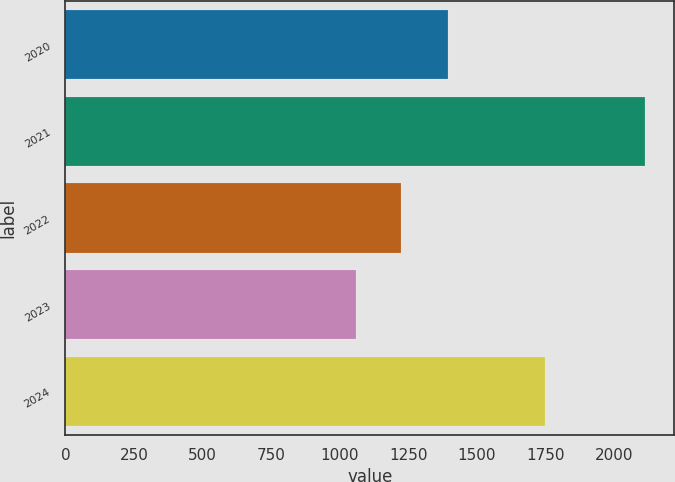Convert chart to OTSL. <chart><loc_0><loc_0><loc_500><loc_500><bar_chart><fcel>2020<fcel>2021<fcel>2022<fcel>2023<fcel>2024<nl><fcel>1396.5<fcel>2114.4<fcel>1224.1<fcel>1060.2<fcel>1750<nl></chart> 